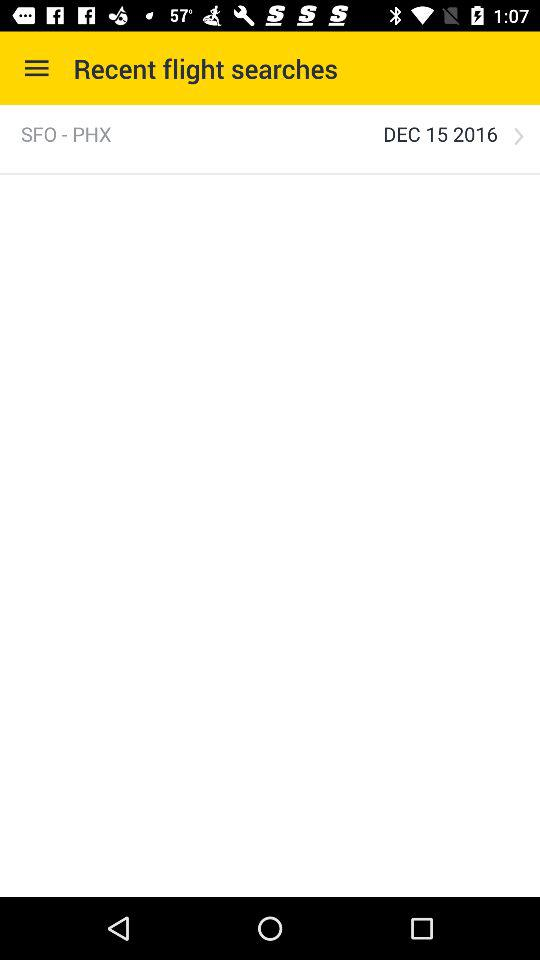Which airports are given in the flight search? The given airports are SFO and PHX. 